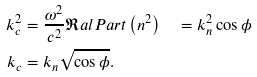Convert formula to latex. <formula><loc_0><loc_0><loc_500><loc_500>k _ { c } ^ { 2 } & = \frac { \omega ^ { 2 } } { c ^ { 2 } } { \Re a l P a r t \left ( n ^ { 2 } \right ) } \quad = k _ { n } ^ { 2 } \cos \phi \\ k _ { c } & = k _ { n } \sqrt { \cos \phi } .</formula> 